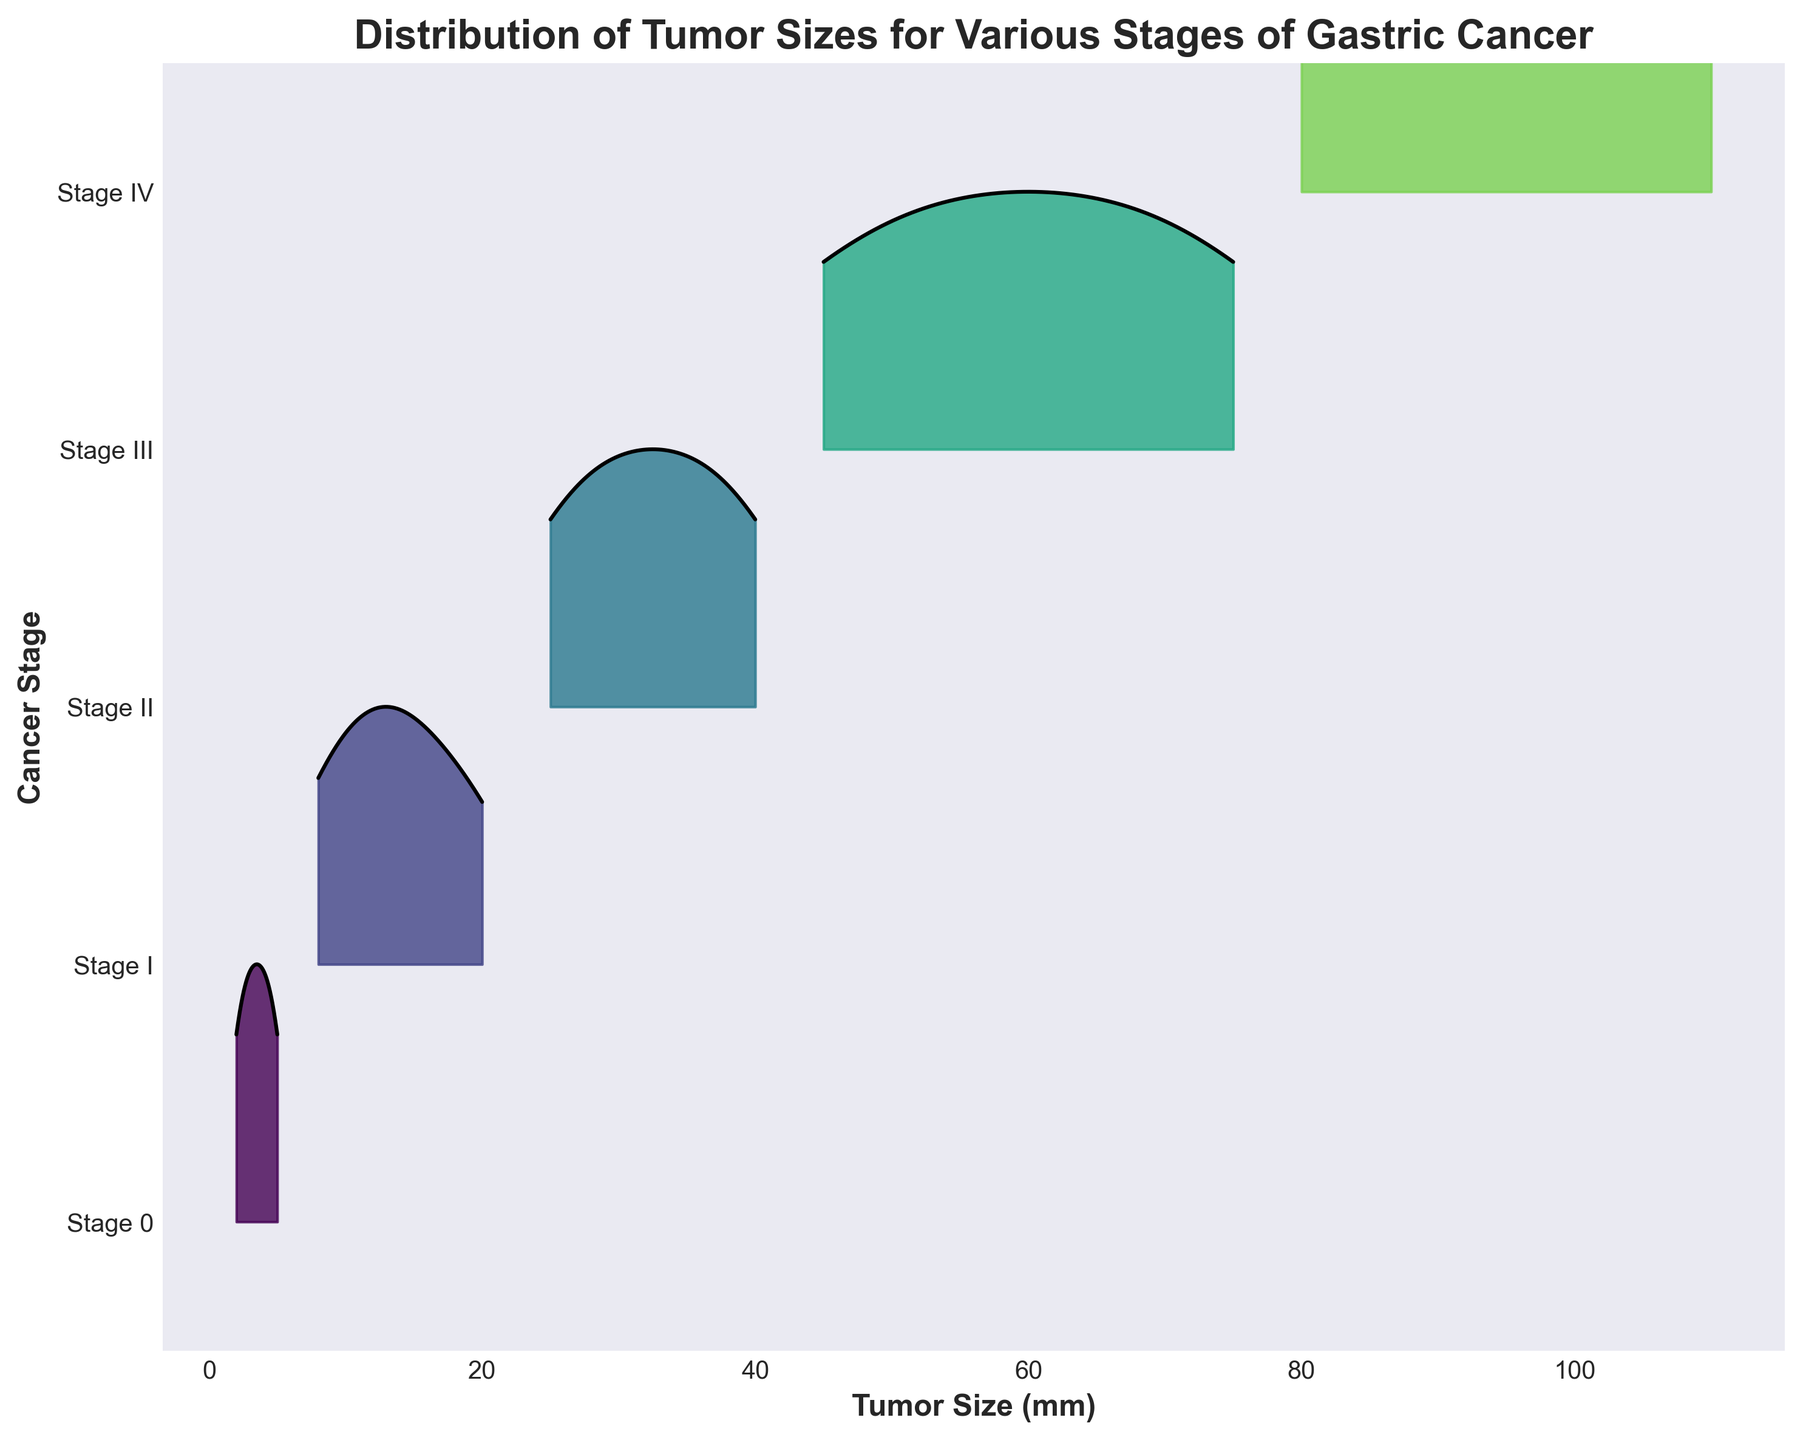What is the title of the figure? The title is usually located at the top of the plot and can be identified by its larger and bold font. In this case, it's "Distribution of Tumor Sizes for Various Stages of Gastric Cancer".
Answer: Distribution of Tumor Sizes for Various Stages of Gastric Cancer What is the x-axis label and what does it represent? The x-axis label is located along the horizontal bottom side of the plot and describes what the horizontal scale represents. It is labeled "Tumor Size (mm)", indicating that the x-axis measures tumor sizes in millimeters.
Answer: Tumor Size (mm) Which stage has the largest observed tumor size and what is its approximate size? To find the largest observed tumor size, look for the farthest right point on the plot. Stage IV extends to approximately 110 mm, which is the largest size.
Answer: Stage IV, 110 mm How many stages are shown in the plot? The number of stages can be determined by counting the unique categories along the y-axis. There are five stages listed: Stage 0, Stage I, Stage II, Stage III, and Stage IV.
Answer: Five stages What is the trend in tumor size as the stage of gastric cancer increases? By examining the ridgeline plot, observe that as the stages progress from 0 to IV, the tumor sizes tend to increase. Early stages have smaller tumor sizes, whereas later stages show larger tumor sizes. This is illustrated by the increasing rightward shift of the distributions.
Answer: Tumor size increases with the stage Which stage has the narrowest distribution of tumor sizes? The narrowest distribution will have the least spread of the curve. Stage 0 shows the narrowest distribution, indicated by its relatively compact range (2 mm to 5 mm).
Answer: Stage 0 What is the most common tumor size interval for Stage III gastric cancer? The highest peak within Stage III's distribution on the plot indicates the most common sizes. The peak is around the interval of 55 to 65 mm, suggesting these are the most frequent sizes for this stage.
Answer: 55 to 65 mm How does the distribution of tumor sizes for Stage II compare to Stage I? By examining the ridgelines, we can see that Stage II tumor sizes are generally larger and more spread out than those of Stage I. Stage I peaks around 8 to 20 mm, while Stage II peaks and spreads over a larger range, from 25 to 40 mm.
Answer: Stage II has larger and more spread out sizes than Stage I Across the stages, which has the most variability in tumor size and how can you tell? The stage with the most variability will have the widest spread in its distribution. Stage IV shows the highest variability, as its distribution extends from around 80 mm to 110 mm, a range of 30 mm.
Answer: Stage IV What is the approximate range of tumor sizes for Stage 0? The range can be determined by identifying the minimum and maximum limits of the Stage 0 distribution. Stage 0 ranges from approximately 2 mm to 5 mm.
Answer: 2 mm to 5 mm 